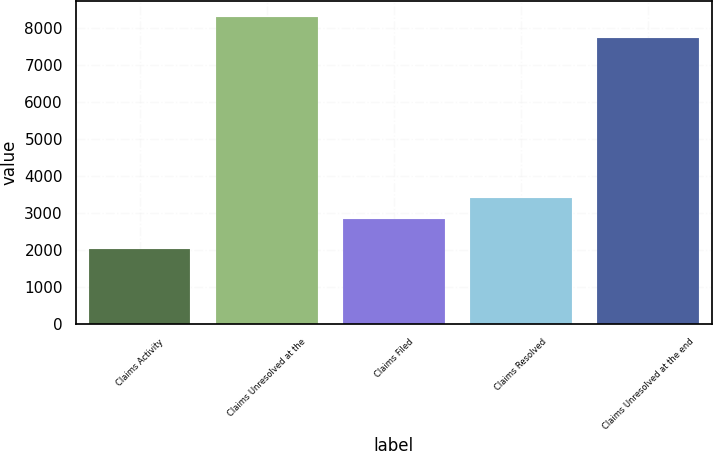Convert chart. <chart><loc_0><loc_0><loc_500><loc_500><bar_chart><fcel>Claims Activity<fcel>Claims Unresolved at the<fcel>Claims Filed<fcel>Claims Resolved<fcel>Claims Unresolved at the end<nl><fcel>2016<fcel>8300.3<fcel>2830<fcel>3406.3<fcel>7724<nl></chart> 